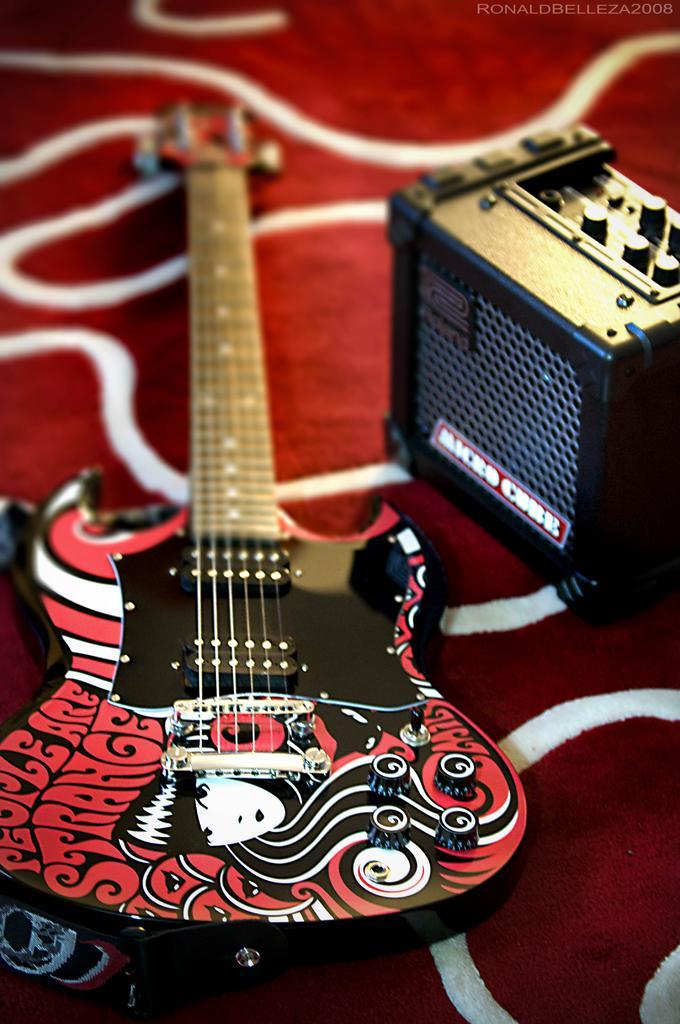How would you summarize this image in a sentence or two? In this image we can see a guitar and some object are placed on the surface of the carpet. 